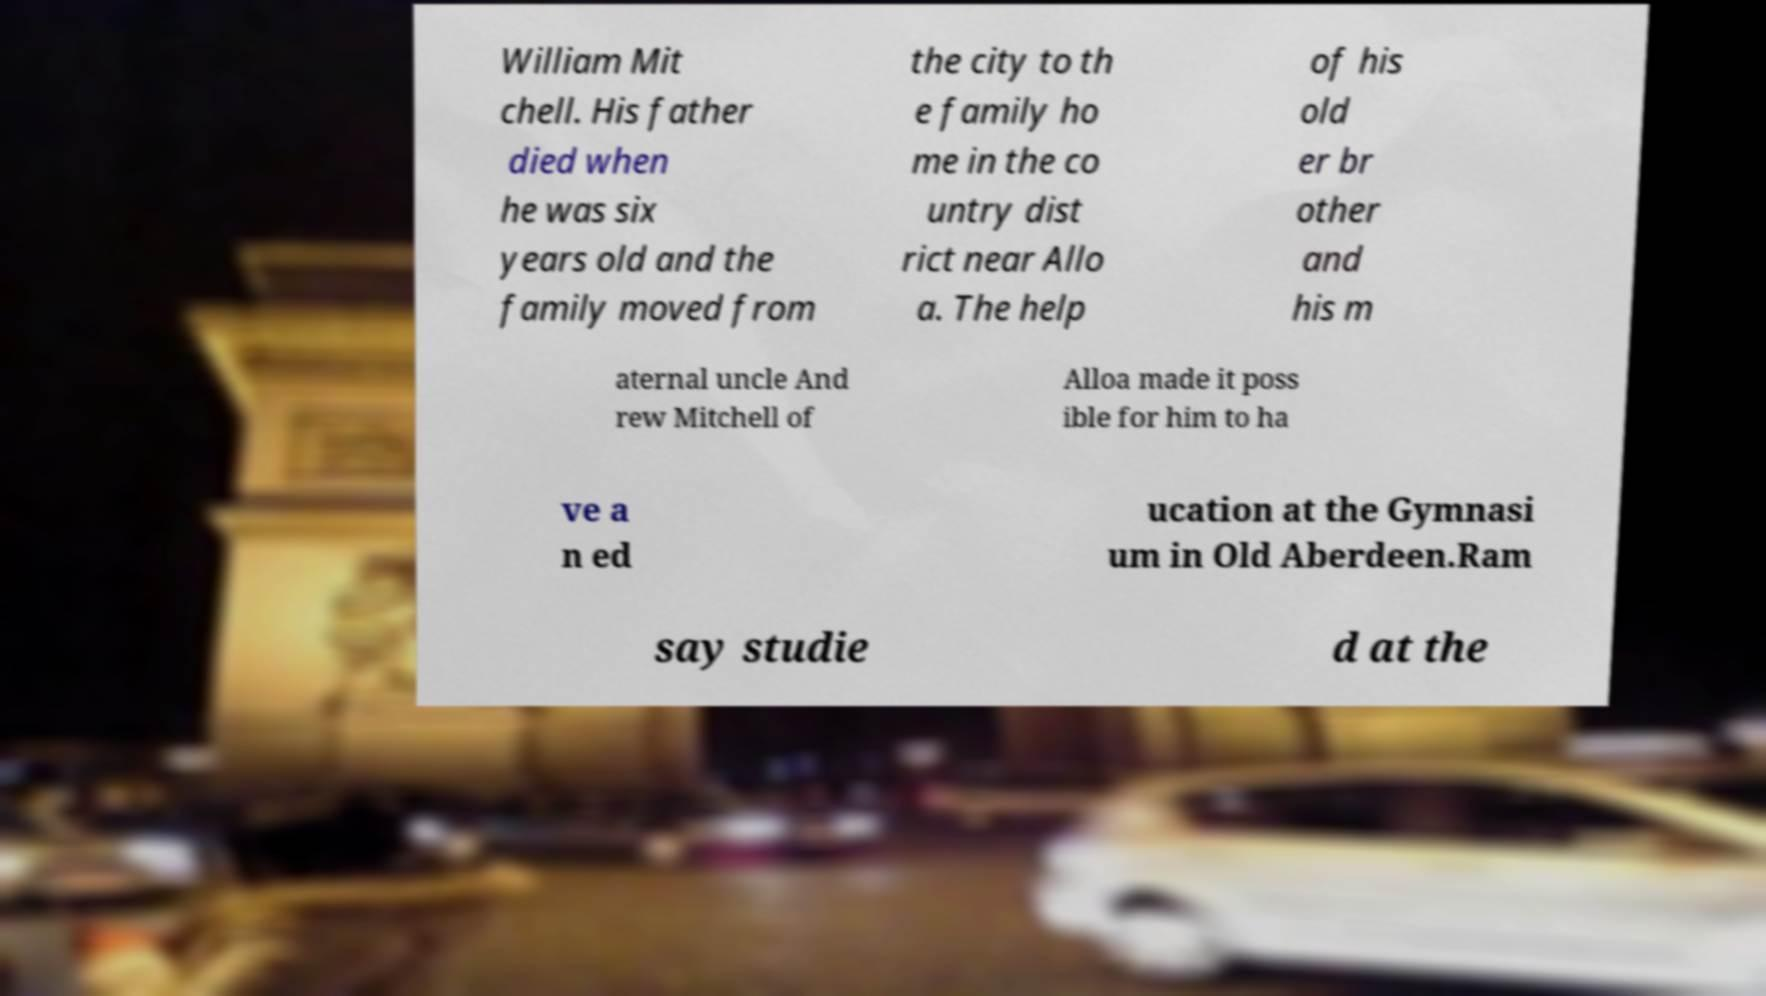What messages or text are displayed in this image? I need them in a readable, typed format. William Mit chell. His father died when he was six years old and the family moved from the city to th e family ho me in the co untry dist rict near Allo a. The help of his old er br other and his m aternal uncle And rew Mitchell of Alloa made it poss ible for him to ha ve a n ed ucation at the Gymnasi um in Old Aberdeen.Ram say studie d at the 